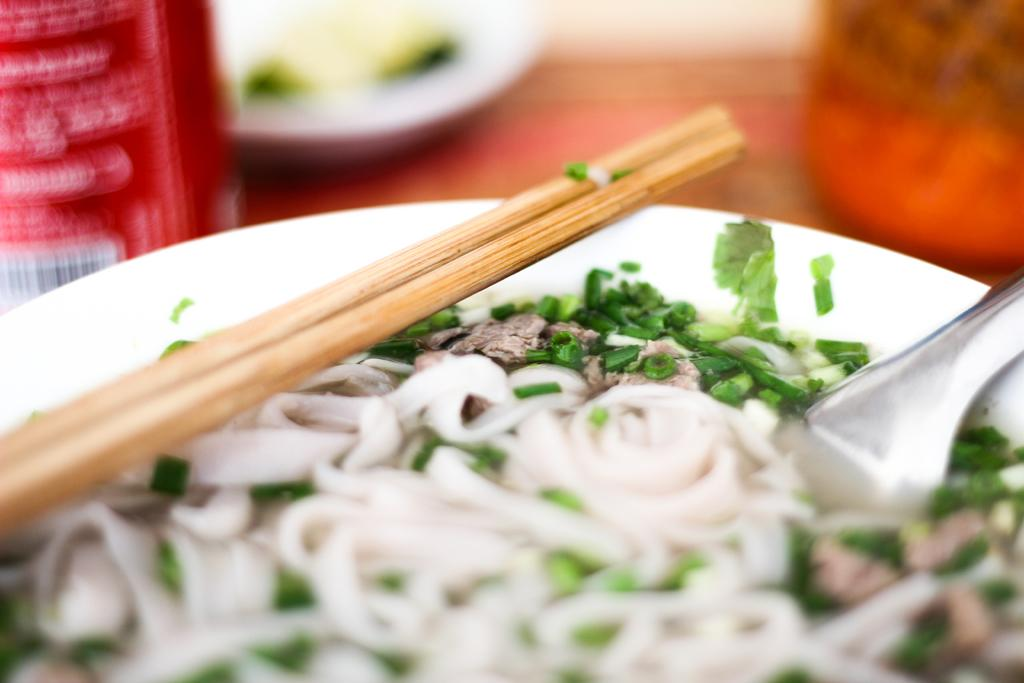What is present on the plate in the image? There are eatables on the plate in the image. What utensils are visible in the image? There is a spoon and chopsticks in the image. Where is the plate located? The plate is placed on a table. What type of pickle is being served in the building shown in the image? There is no pickle or building present in the image; it only features a plate with eatables, a spoon, and chopsticks on a table. 